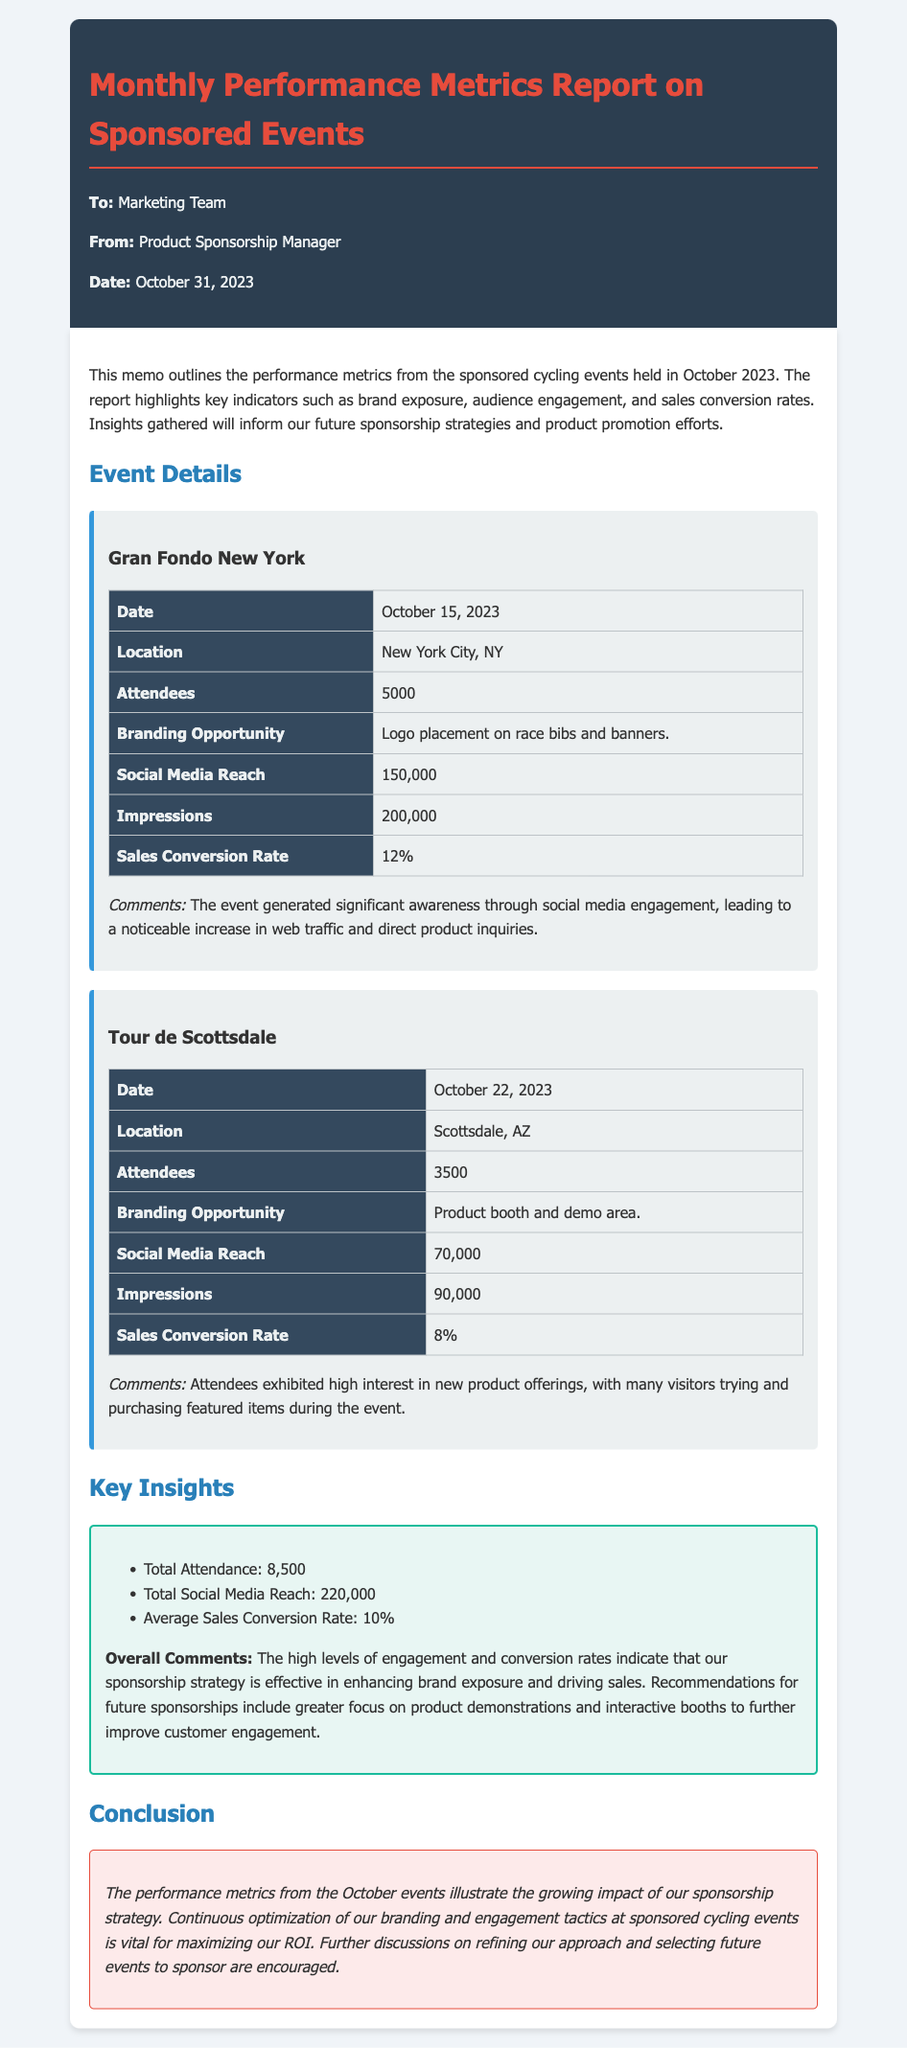what is the date of the Gran Fondo New York event? The date of the Gran Fondo New York event is mentioned in the document as October 15, 2023.
Answer: October 15, 2023 how many attendees were at the Tour de Scottsdale? The document states that the number of attendees at the Tour de Scottsdale was 3500.
Answer: 3500 what was the social media reach for the Gran Fondo New York? According to the report, the social media reach for the Gran Fondo New York was 150,000.
Answer: 150,000 what was the average sales conversion rate across the events? The average sales conversion rate is calculated from the provided metrics in the document, which indicates an average of 10%.
Answer: 10% how many total attendees were recorded across both events? The document adds the attendees from both events: 5000 (Gran Fondo) and 3500 (Tour de Scottsdale), resulting in a total of 8500.
Answer: 8500 what branding opportunity was available at the Tour de Scottsdale? The Tour de Scottsdale offered a product booth and demo area for branding purposes.
Answer: Product booth and demo area what do attendees at the Gran Fondo New York event show interest in? The comments mention significant awareness and increased web traffic, indicating strong interest in the products.
Answer: Interest in products what are the key insights related to brand exposure? The total social media reach noted in the report summarizes brand exposure across the events: 220,000.
Answer: 220,000 what is the conclusion regarding the sponsorship strategy? The conclusion emphasizes the importance of continuous optimization of branding tactics to maximize ROI.
Answer: Optimize branding tactics 